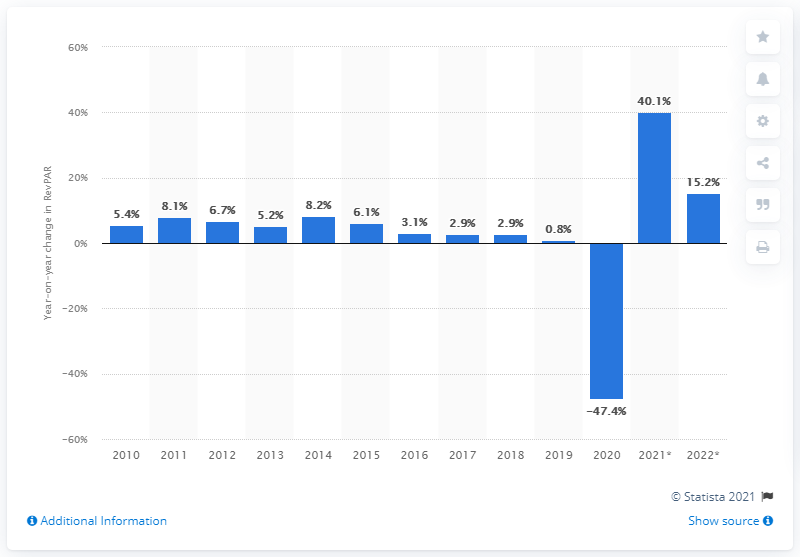Give some essential details in this illustration. The revenue per available room in the U.S. lodging industry for the previous year was 0.8. According to the prediction, the revenue per available room (RevPAR) is expected to increase by X percent in 2021. 